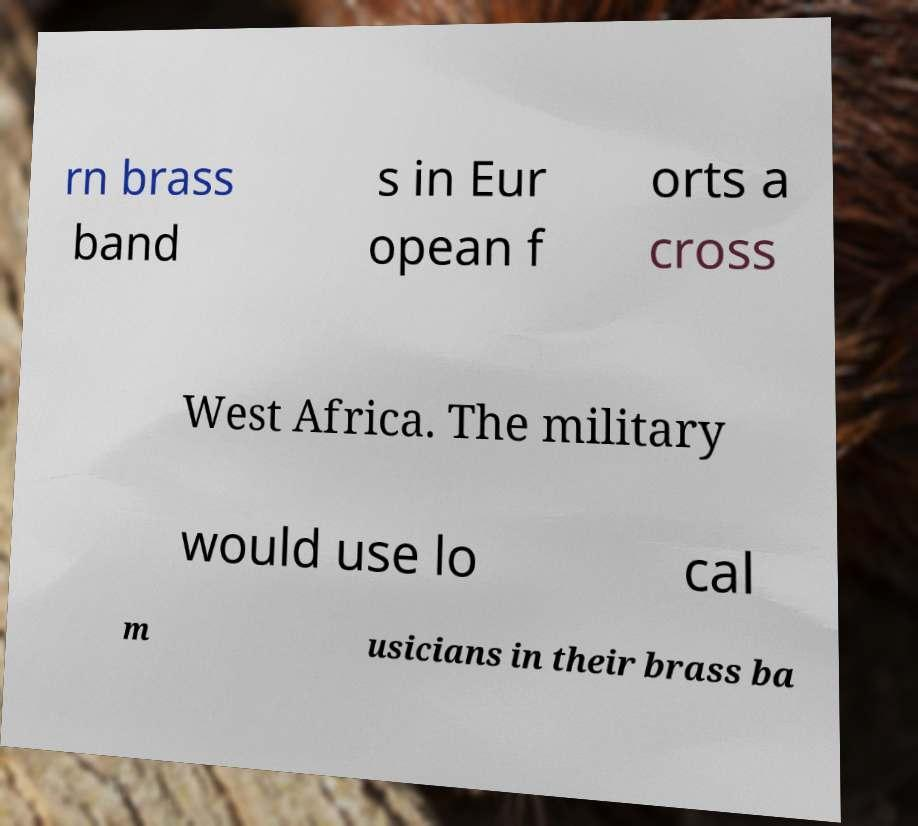Please read and relay the text visible in this image. What does it say? rn brass band s in Eur opean f orts a cross West Africa. The military would use lo cal m usicians in their brass ba 